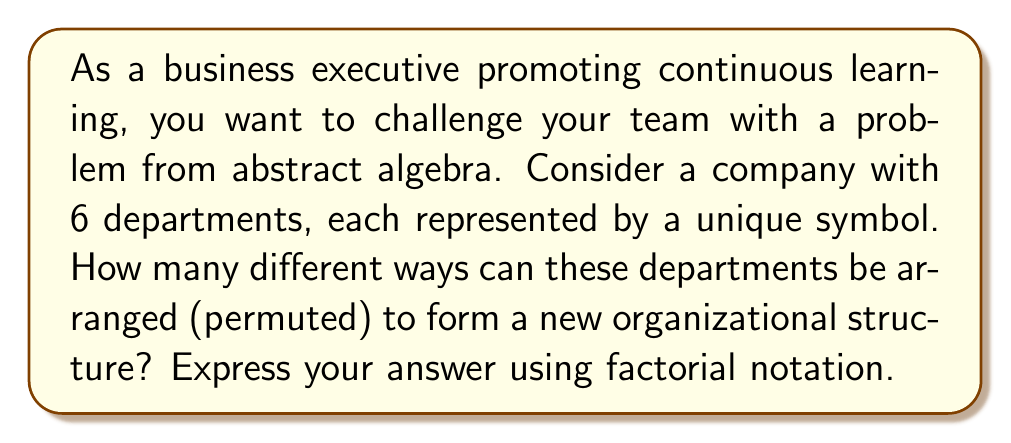Help me with this question. To solve this problem, we need to understand the concept of symmetric groups and permutations:

1) In abstract algebra, the symmetric group on a set of $n$ elements, denoted as $S_n$, is the group of all permutations of these $n$ elements.

2) A permutation is a rearrangement of the elements in a set. The number of permutations of $n$ distinct objects is given by $n!$ (n factorial).

3) In this case, we have 6 departments, so we're dealing with $S_6$.

4) To calculate the number of unique permutations:
   
   - For the first position, we have 6 choices
   - For the second position, we have 5 remaining choices
   - For the third position, we have 4 remaining choices
   - And so on...

5) Therefore, the total number of permutations is:

   $$ 6 \times 5 \times 4 \times 3 \times 2 \times 1 = 6! $$

This calculation represents all possible ways to arrange the 6 departments, which is equivalent to the order of the symmetric group $S_6$.
Answer: $6! = 720$ 